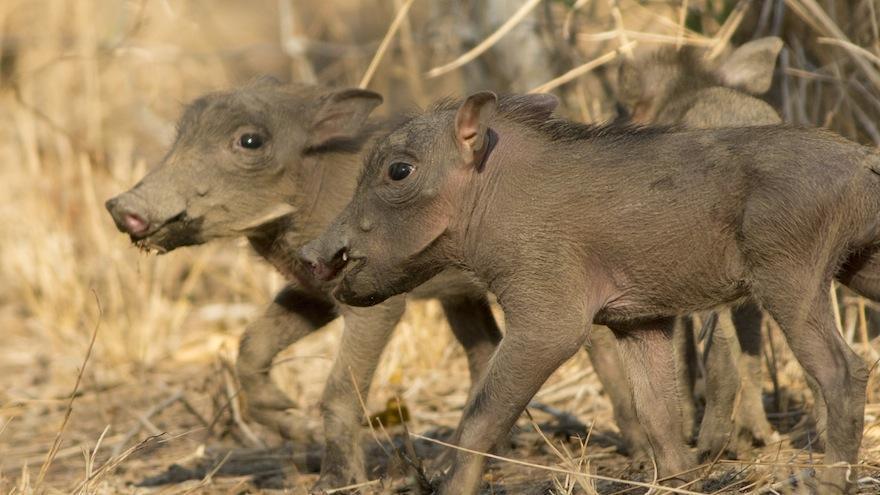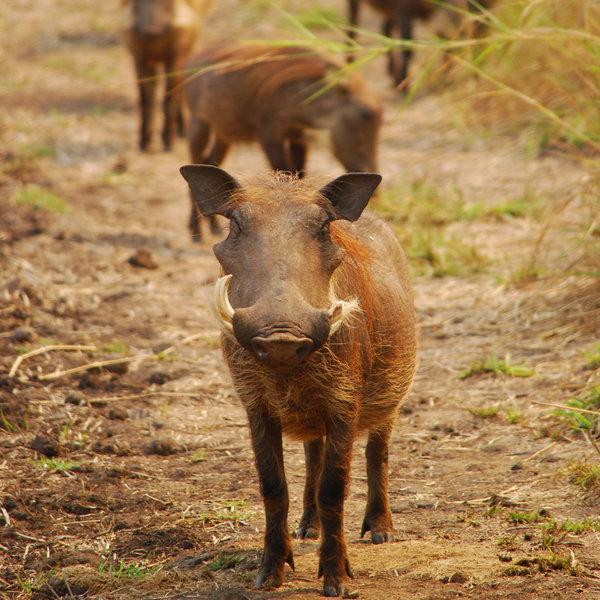The first image is the image on the left, the second image is the image on the right. Examine the images to the left and right. Is the description "An image shows one adult warthog near two small young warthogs." accurate? Answer yes or no. No. The first image is the image on the left, the second image is the image on the right. Evaluate the accuracy of this statement regarding the images: "Baby warthogs are standing close to their mother.". Is it true? Answer yes or no. No. 